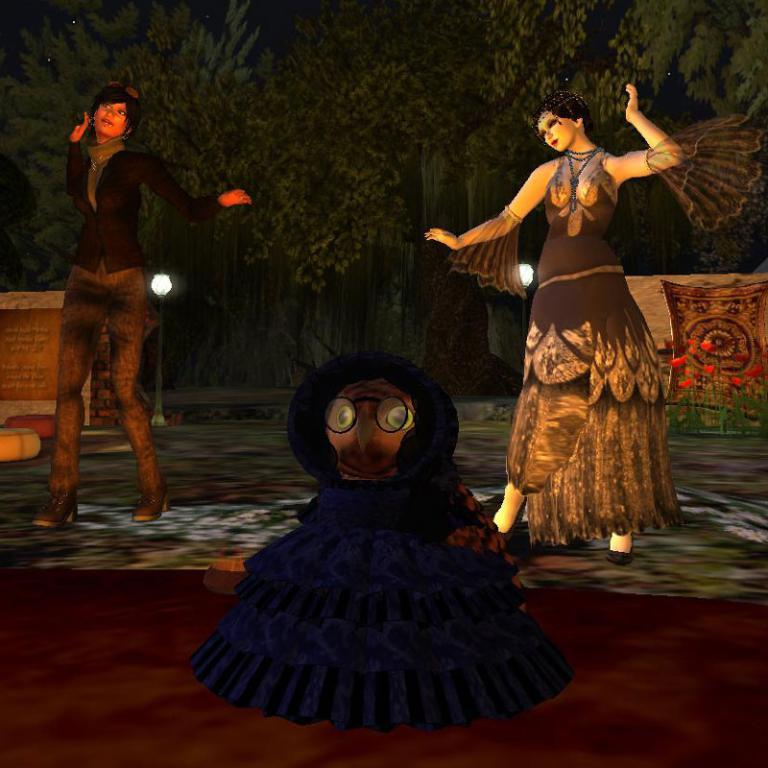What type of image is being described? The image is animated. What are the two women in the image doing? The two women are dancing in the image. What can be seen in the foreground of the image? There is a toy in the foreground of the image. What type of natural scenery is visible in the background of the image? There are trees in the background of the image. How many cherries are on the secretary's desk in the image? There is no secretary or desk present in the image, and therefore no cherries can be observed. 